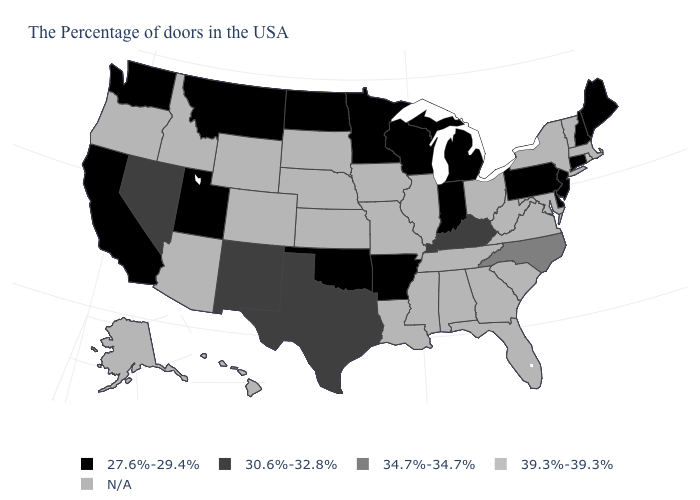Which states hav the highest value in the South?
Answer briefly. North Carolina. What is the value of Nevada?
Short answer required. 30.6%-32.8%. What is the highest value in the USA?
Keep it brief. 39.3%-39.3%. Name the states that have a value in the range N/A?
Short answer required. Massachusetts, Vermont, New York, Maryland, Virginia, South Carolina, West Virginia, Ohio, Florida, Georgia, Alabama, Tennessee, Illinois, Mississippi, Louisiana, Missouri, Iowa, Kansas, Nebraska, South Dakota, Wyoming, Colorado, Arizona, Idaho, Oregon, Alaska, Hawaii. Does the first symbol in the legend represent the smallest category?
Keep it brief. Yes. Which states have the lowest value in the USA?
Quick response, please. Maine, New Hampshire, Connecticut, New Jersey, Delaware, Pennsylvania, Michigan, Indiana, Wisconsin, Arkansas, Minnesota, Oklahoma, North Dakota, Utah, Montana, California, Washington. Name the states that have a value in the range 39.3%-39.3%?
Write a very short answer. Rhode Island. What is the highest value in states that border Maryland?
Quick response, please. 27.6%-29.4%. Name the states that have a value in the range 34.7%-34.7%?
Be succinct. North Carolina. Which states hav the highest value in the West?
Be succinct. New Mexico, Nevada. Which states hav the highest value in the South?
Quick response, please. North Carolina. What is the value of Wisconsin?
Write a very short answer. 27.6%-29.4%. Name the states that have a value in the range 34.7%-34.7%?
Give a very brief answer. North Carolina. What is the value of Maine?
Write a very short answer. 27.6%-29.4%. Does the map have missing data?
Give a very brief answer. Yes. 